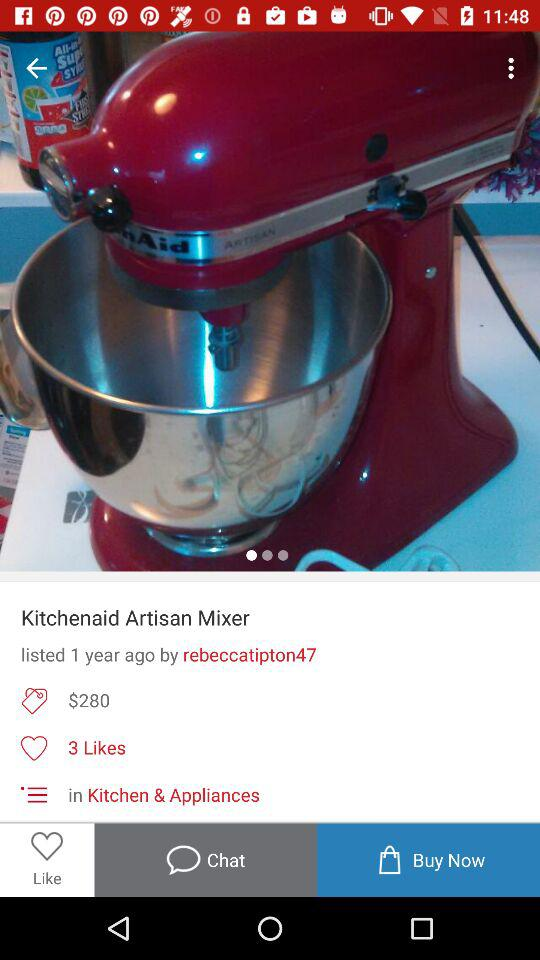What is the price of the "Kitchenaid Artisan Mixer"? The price is $280. 